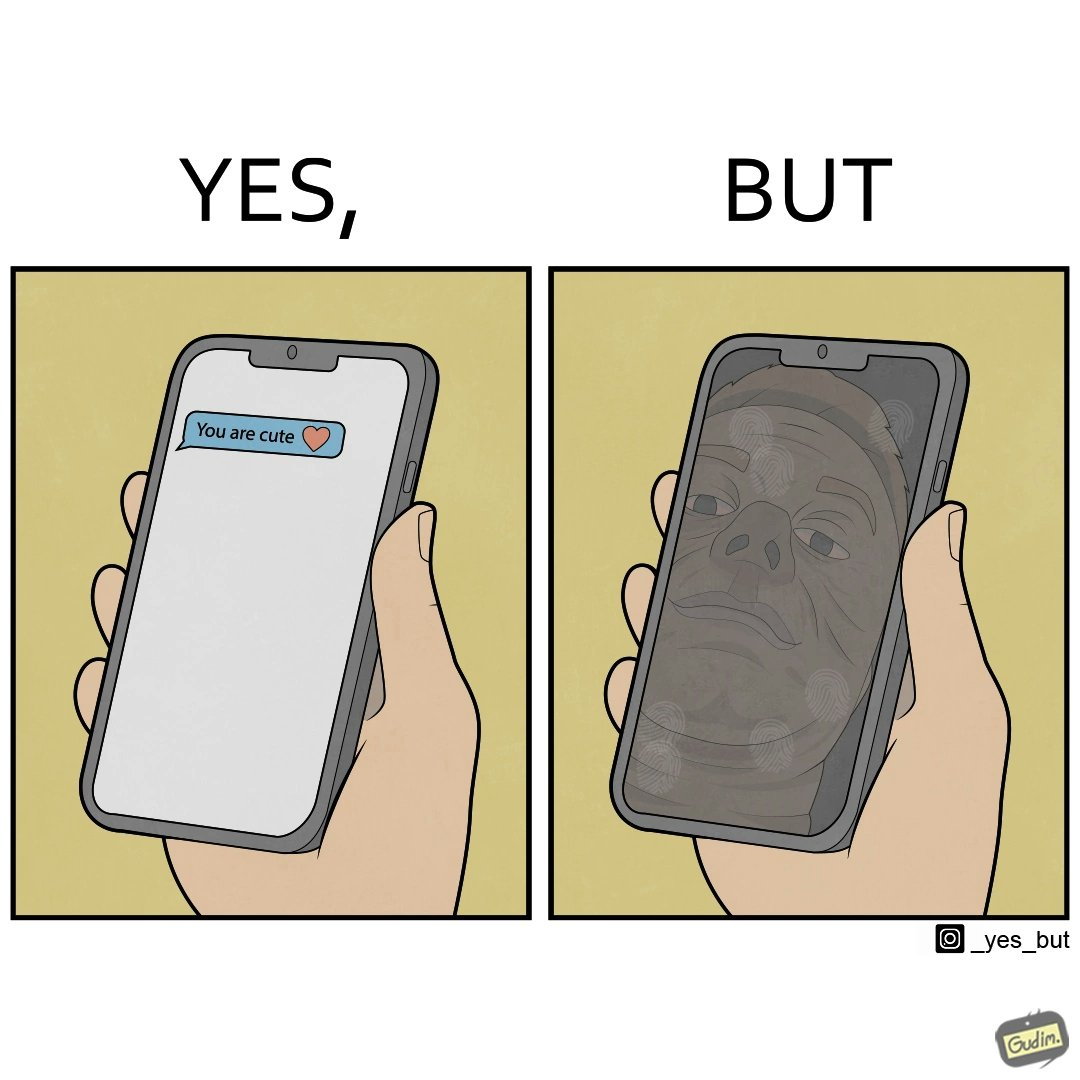Describe the content of this image. The image is ironic, because person who received the text saying "you are cute" is apparently not good looking according to the beautyÃÂ standards 